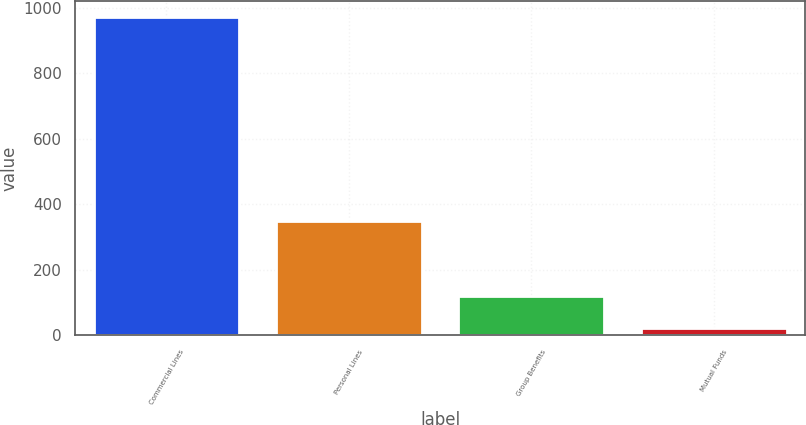Convert chart. <chart><loc_0><loc_0><loc_500><loc_500><bar_chart><fcel>Commercial Lines<fcel>Personal Lines<fcel>Group Benefits<fcel>Mutual Funds<nl><fcel>973<fcel>348<fcel>118.9<fcel>24<nl></chart> 